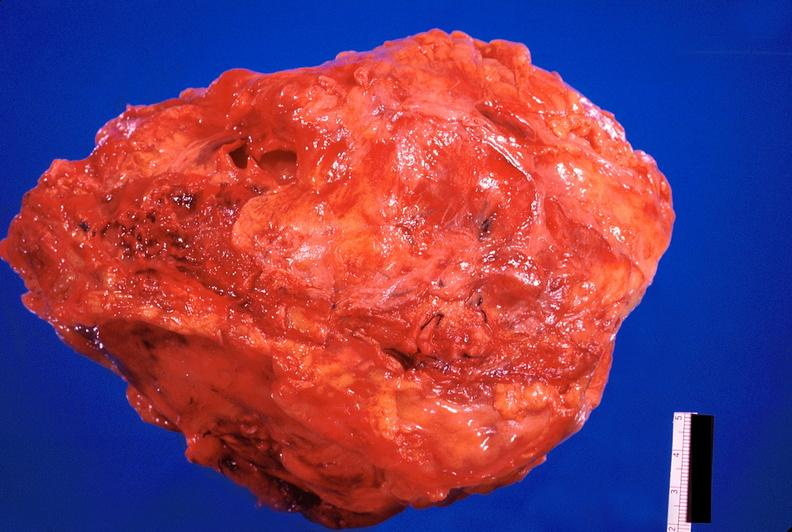what is present?
Answer the question using a single word or phrase. Cardiovascular 